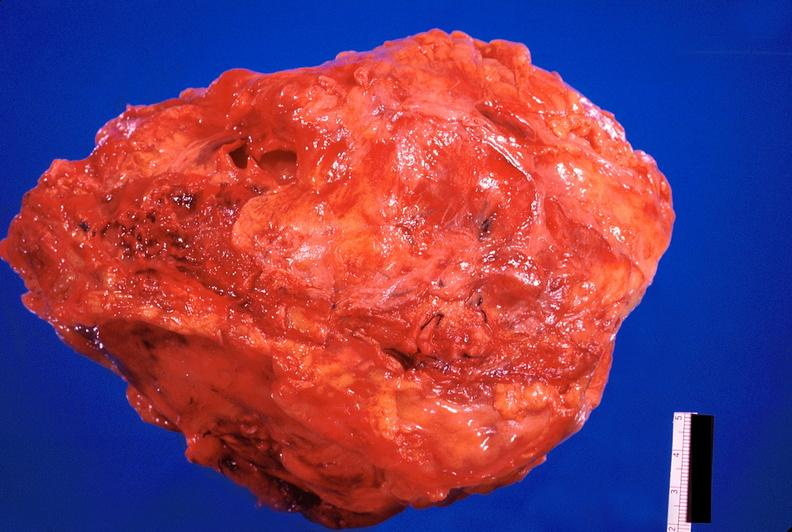what is present?
Answer the question using a single word or phrase. Cardiovascular 